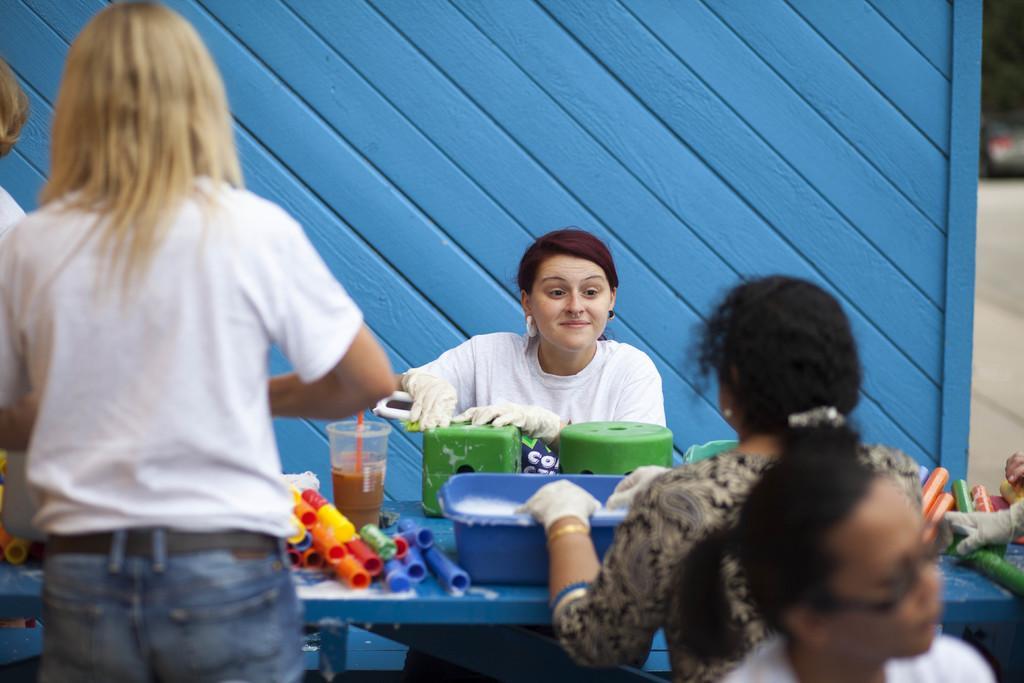In one or two sentences, can you explain what this image depicts? In this image I can see people among them this woman is holding an object in hands. Among these people some are standing and some are sitting. On the table I can see a glass, a tray and some other objects. In the background I can see a wall. 